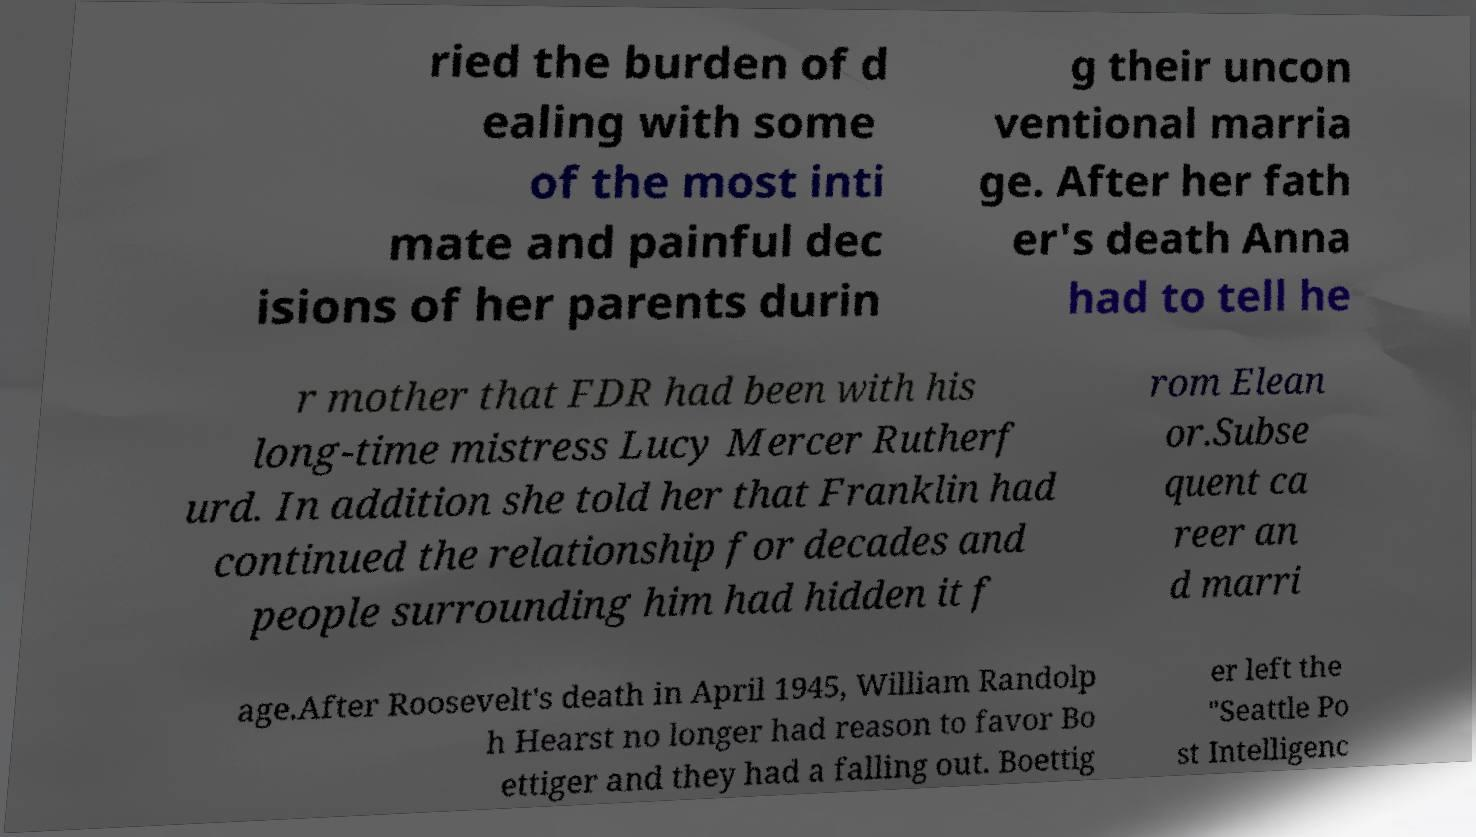Can you read and provide the text displayed in the image?This photo seems to have some interesting text. Can you extract and type it out for me? ried the burden of d ealing with some of the most inti mate and painful dec isions of her parents durin g their uncon ventional marria ge. After her fath er's death Anna had to tell he r mother that FDR had been with his long-time mistress Lucy Mercer Rutherf urd. In addition she told her that Franklin had continued the relationship for decades and people surrounding him had hidden it f rom Elean or.Subse quent ca reer an d marri age.After Roosevelt's death in April 1945, William Randolp h Hearst no longer had reason to favor Bo ettiger and they had a falling out. Boettig er left the "Seattle Po st Intelligenc 